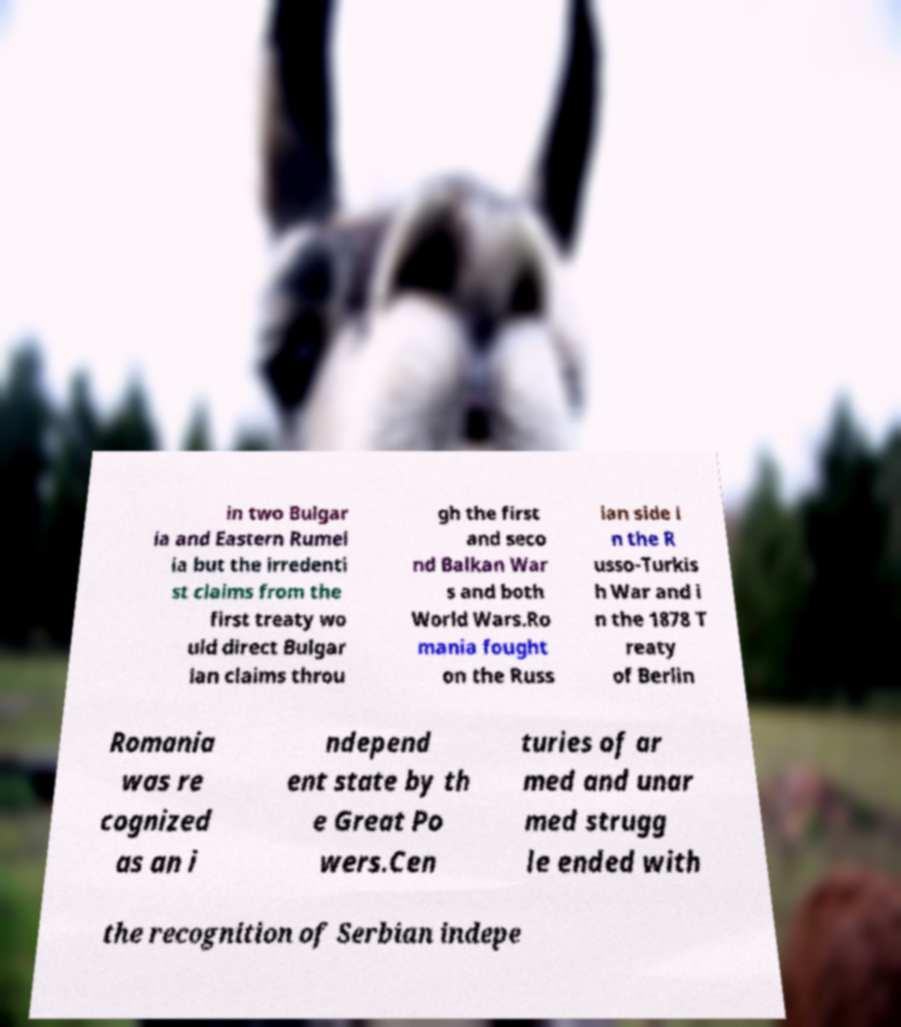Can you read and provide the text displayed in the image?This photo seems to have some interesting text. Can you extract and type it out for me? in two Bulgar ia and Eastern Rumel ia but the irredenti st claims from the first treaty wo uld direct Bulgar ian claims throu gh the first and seco nd Balkan War s and both World Wars.Ro mania fought on the Russ ian side i n the R usso-Turkis h War and i n the 1878 T reaty of Berlin Romania was re cognized as an i ndepend ent state by th e Great Po wers.Cen turies of ar med and unar med strugg le ended with the recognition of Serbian indepe 